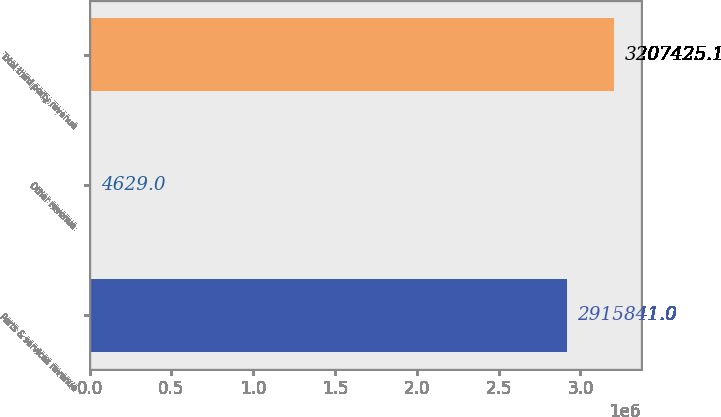Convert chart to OTSL. <chart><loc_0><loc_0><loc_500><loc_500><bar_chart><fcel>Parts & services revenue<fcel>Other revenue<fcel>Total third party revenue<nl><fcel>2.91584e+06<fcel>4629<fcel>3.20743e+06<nl></chart> 